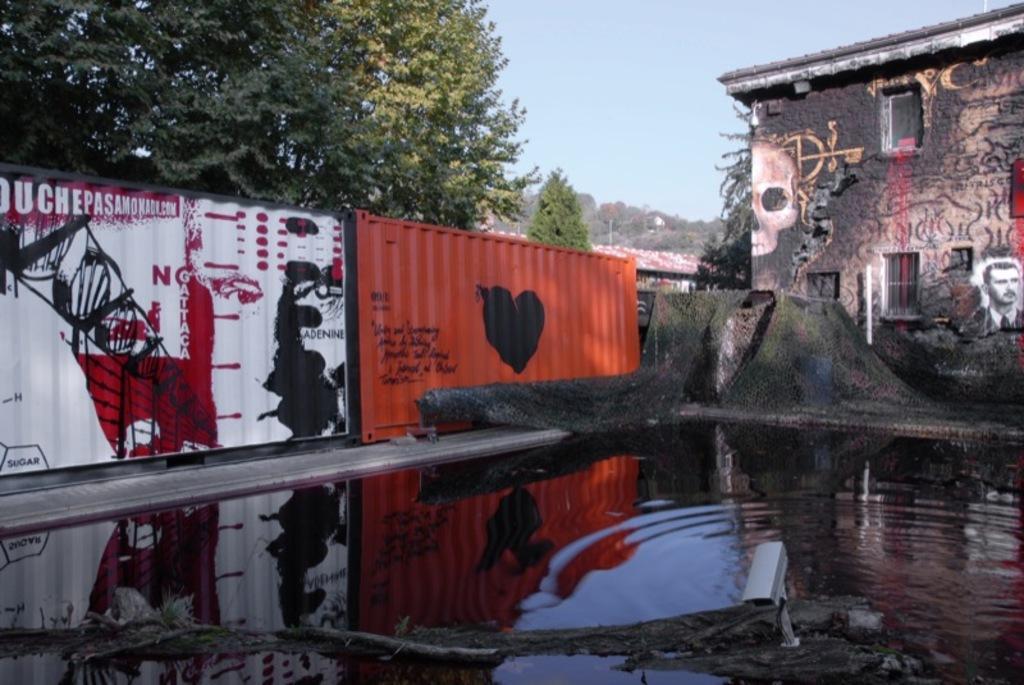How would you summarize this image in a sentence or two? In this image there is water in the middle. In the water there is a net. On the left side there are two containers on which there is some painting. On the right side there is a building on which there is a painting of a skull. Beside the building there is a net. On the left side top there are trees. At the top there is the sky. 